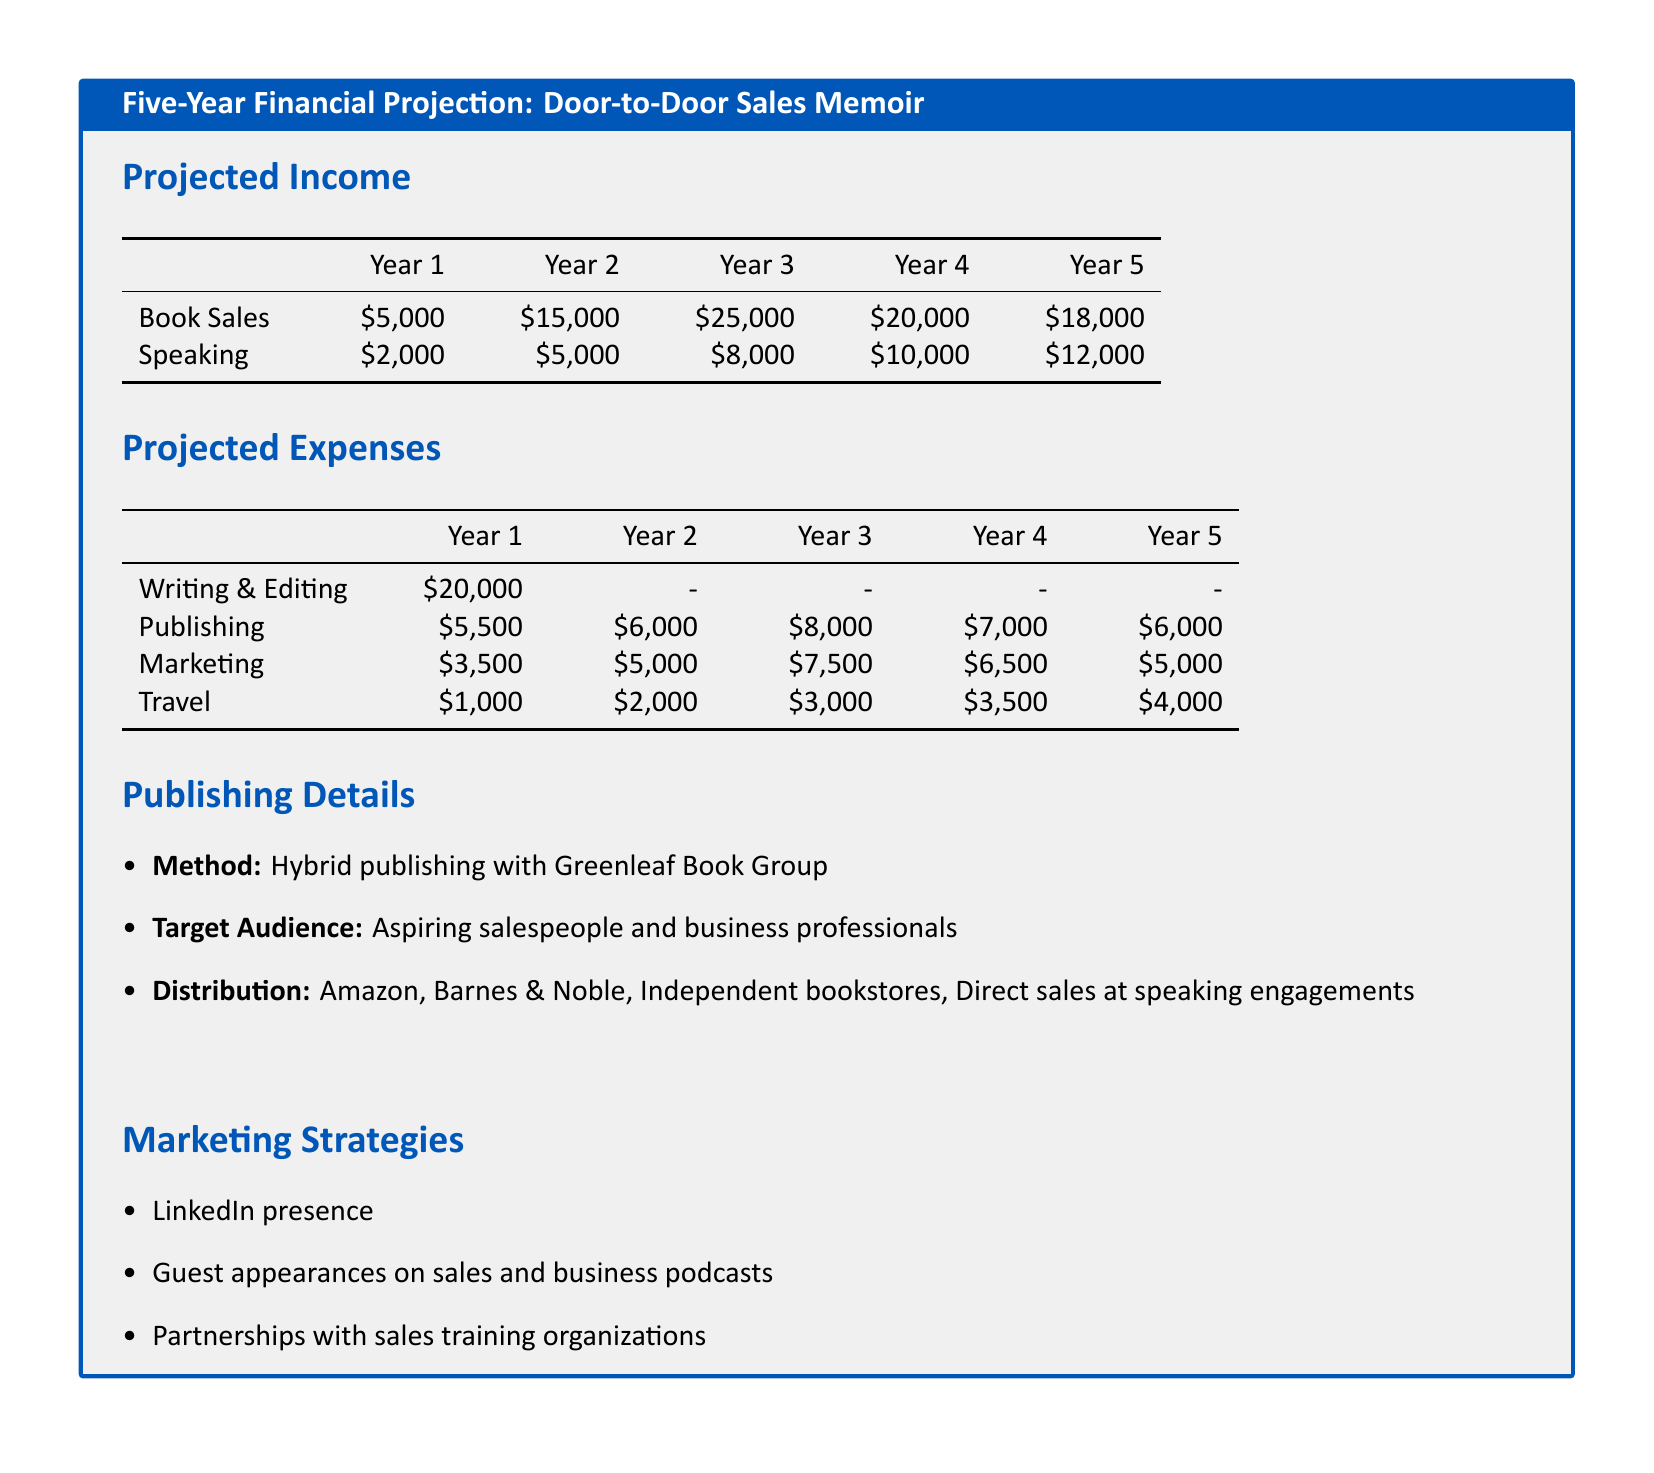What is the projected income from book sales in Year 3? The projected income from book sales in Year 3 is listed in the table under Year 3 for Book Sales, which is $25,000.
Answer: $25,000 What is the total expense for writing and editing? The total expense for writing and editing is listed only for Year 1, which is $20,000.
Answer: $20,000 How much is allocated for marketing in Year 5? The allocation for marketing in Year 5 can be found in the expense table, which is $5,000.
Answer: $5,000 What is the cumulative income from speaking over the five years? The cumulative income from speaking is calculated by adding all the speaking income for each year: $2,000 + $5,000 + $8,000 + $10,000 + $12,000 = $37,000.
Answer: $37,000 What publishing method is used for the memoir? The document specifies that the publishing method is Hybrid publishing with Greenleaf Book Group.
Answer: Hybrid publishing What is the target audience for the memoir? The target audience is mentioned in the publishing details section as aspiring salespeople and business professionals.
Answer: Aspiring salespeople and business professionals What is the highest expense category in Year 2? By reviewing the expense table for Year 2, the highest expense category is Publishing at $6,000.
Answer: Publishing What marketing strategy involves online networking? The document mentions a LinkedIn presence as a marketing strategy focusing on online networking.
Answer: LinkedIn presence What is the distribution method for the memoir? The distribution section states that the memoir will be distributed through Amazon, Barnes & Noble, Independent bookstores, and Direct sales at speaking engagements.
Answer: Amazon, Barnes & Noble, Independent bookstores, Direct sales What is the travel expense in Year 4? The travel expense for Year 4 is found in the expenses table, which is $3,500.
Answer: $3,500 